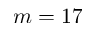Convert formula to latex. <formula><loc_0><loc_0><loc_500><loc_500>m = 1 7</formula> 